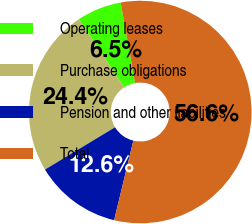Convert chart. <chart><loc_0><loc_0><loc_500><loc_500><pie_chart><fcel>Operating leases<fcel>Purchase obligations<fcel>Pension and other liabilities<fcel>Total<nl><fcel>6.47%<fcel>24.36%<fcel>12.58%<fcel>56.59%<nl></chart> 